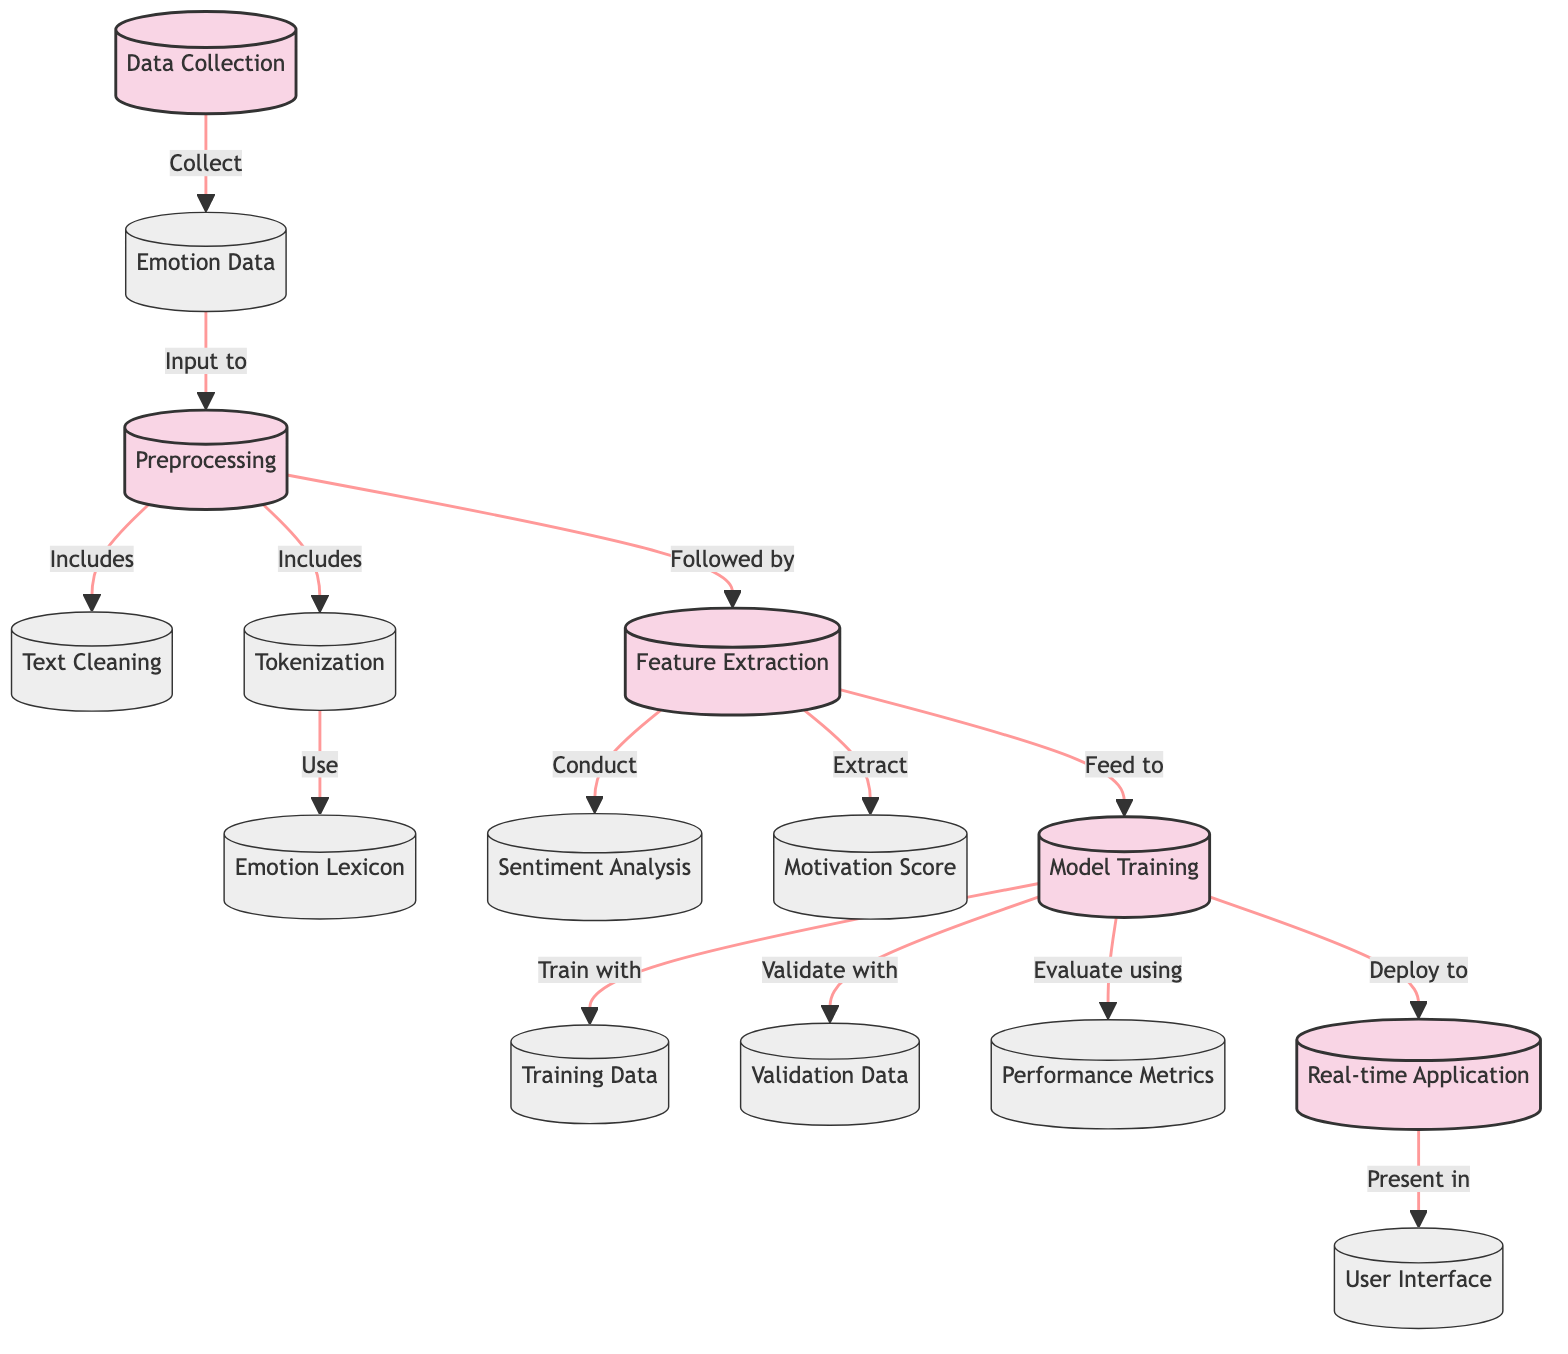What is the first step in the process? The first step in the process is "Data Collection," which is indicated as the first node in the diagram.
Answer: Data Collection How many types of data are shown in the diagram? The diagram shows three types of data: Emotion Data, Training Data, and Validation Data, each represented as distinct nodes connected by arrows.
Answer: Three What comes after Text Cleaning? After Text Cleaning, the process shown proceeds to Tokenization, as indicated by the flow direction in the diagram.
Answer: Tokenization Which process node directly leads to User Interface? The process node that directly leads to the User Interface is Real-time Application, as illustrated by the arrow pointing to it from Model Training.
Answer: Real-time Application What are the two types of data inputs for Model Training? The two types of data inputs for Model Training are Training Data and Validation Data, as each one is connected to the Model Training node in the diagram.
Answer: Training Data and Validation Data Which process is responsible for conducting Sentiment Analysis? The process responsible for conducting Sentiment Analysis is Feature Extraction, which leads to the Sentiment Analysis node, according to the flow of the diagram.
Answer: Feature Extraction What does the model evaluate using? The model evaluates using Performance Metrics, as indicated by the connection from Model Training to Performance Metrics in the diagram.
Answer: Performance Metrics How many preprocessing steps are included before Feature Extraction? There are three preprocessing steps included before Feature Extraction: Text Cleaning, Tokenization, and Emotion Lexicon, totaling to three steps.
Answer: Three What is the last output shown in the diagram? The last output shown in the diagram is the User Interface, which is the final node connected to Real-time Application at the end of the flow.
Answer: User Interface 